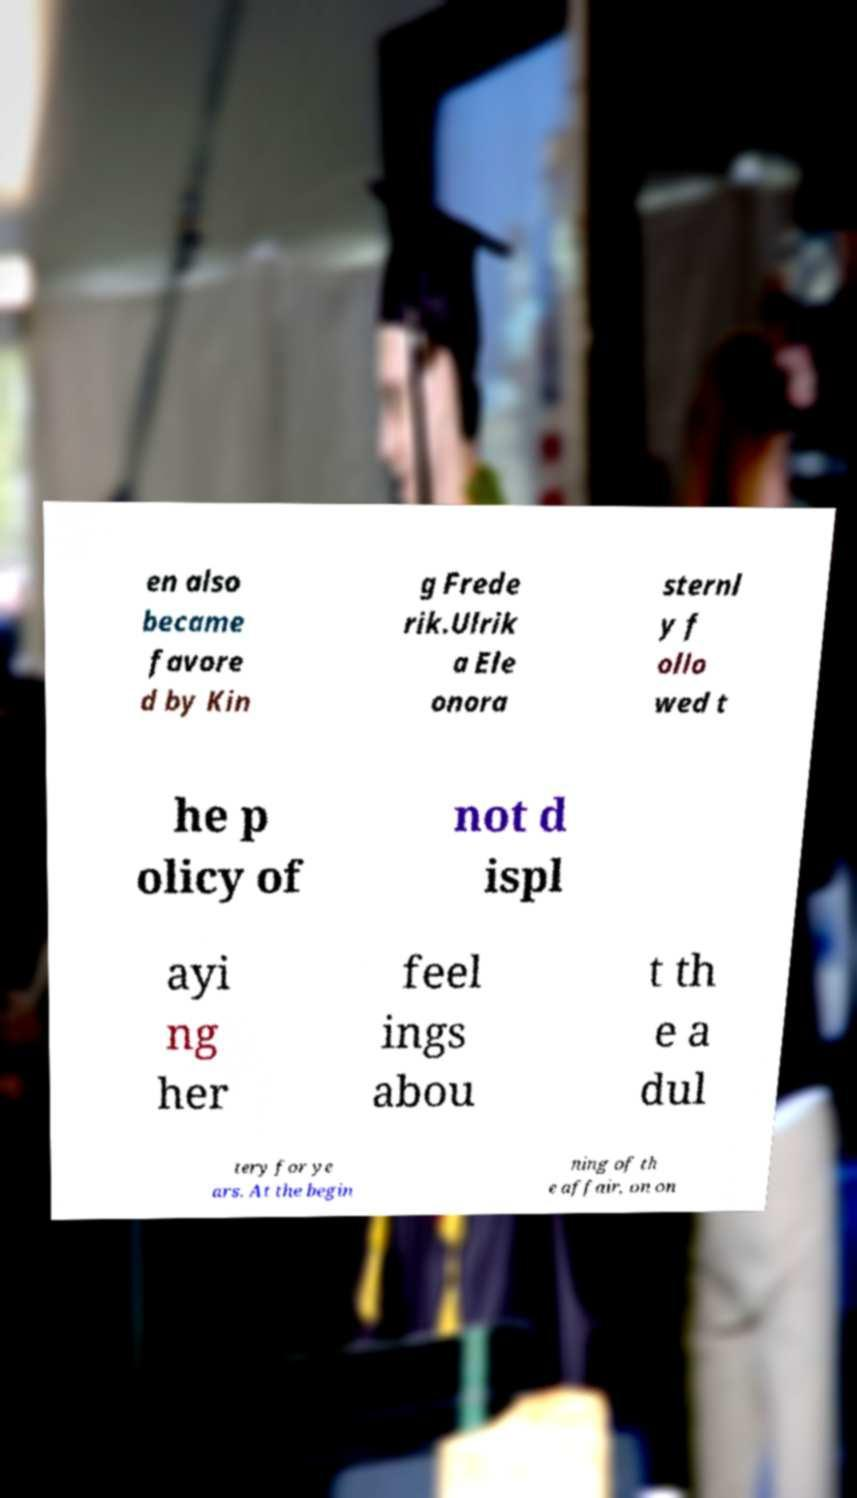I need the written content from this picture converted into text. Can you do that? en also became favore d by Kin g Frede rik.Ulrik a Ele onora sternl y f ollo wed t he p olicy of not d ispl ayi ng her feel ings abou t th e a dul tery for ye ars. At the begin ning of th e affair, on on 